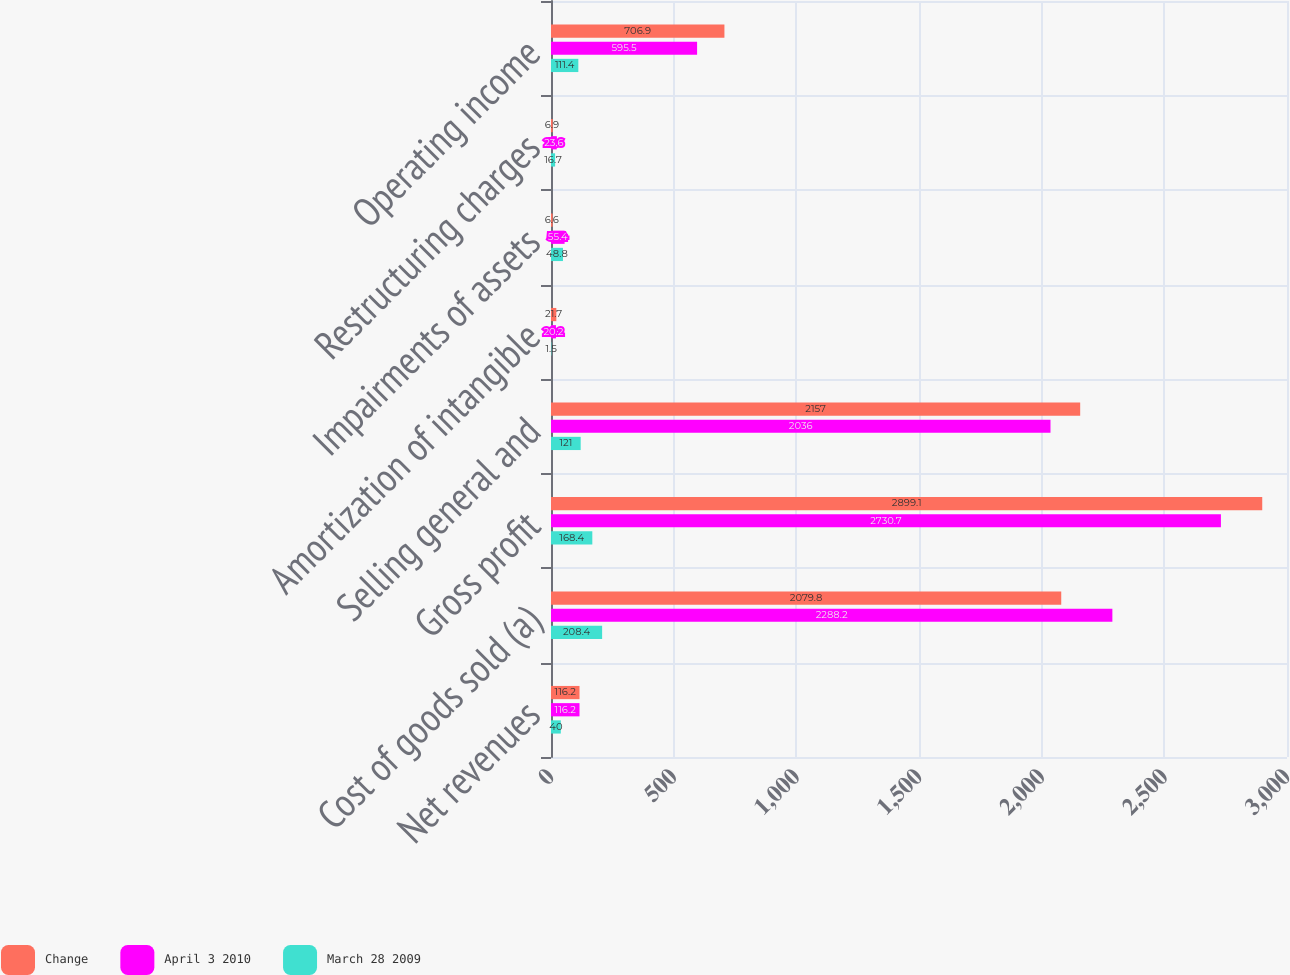Convert chart to OTSL. <chart><loc_0><loc_0><loc_500><loc_500><stacked_bar_chart><ecel><fcel>Net revenues<fcel>Cost of goods sold (a)<fcel>Gross profit<fcel>Selling general and<fcel>Amortization of intangible<fcel>Impairments of assets<fcel>Restructuring charges<fcel>Operating income<nl><fcel>Change<fcel>116.2<fcel>2079.8<fcel>2899.1<fcel>2157<fcel>21.7<fcel>6.6<fcel>6.9<fcel>706.9<nl><fcel>April 3 2010<fcel>116.2<fcel>2288.2<fcel>2730.7<fcel>2036<fcel>20.2<fcel>55.4<fcel>23.6<fcel>595.5<nl><fcel>March 28 2009<fcel>40<fcel>208.4<fcel>168.4<fcel>121<fcel>1.5<fcel>48.8<fcel>16.7<fcel>111.4<nl></chart> 